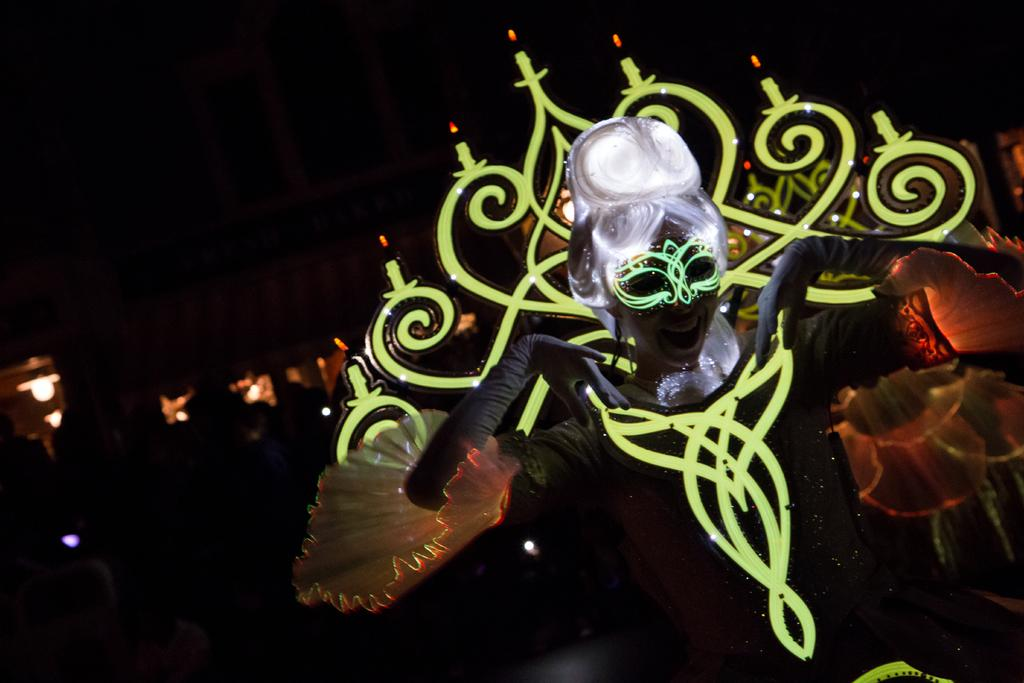Who or what is the main subject in the image? There is a person in the image. What is the person wearing? The person is wearing a fancy dress. What can be seen behind the person in the image? There is a dark background in the image. What else is present in the image besides the person? Lights are present in the image. How does the person's mouth look while they are eating a volcano in the image? There is no volcano present in the image, and the person's mouth is not shown while eating anything. 